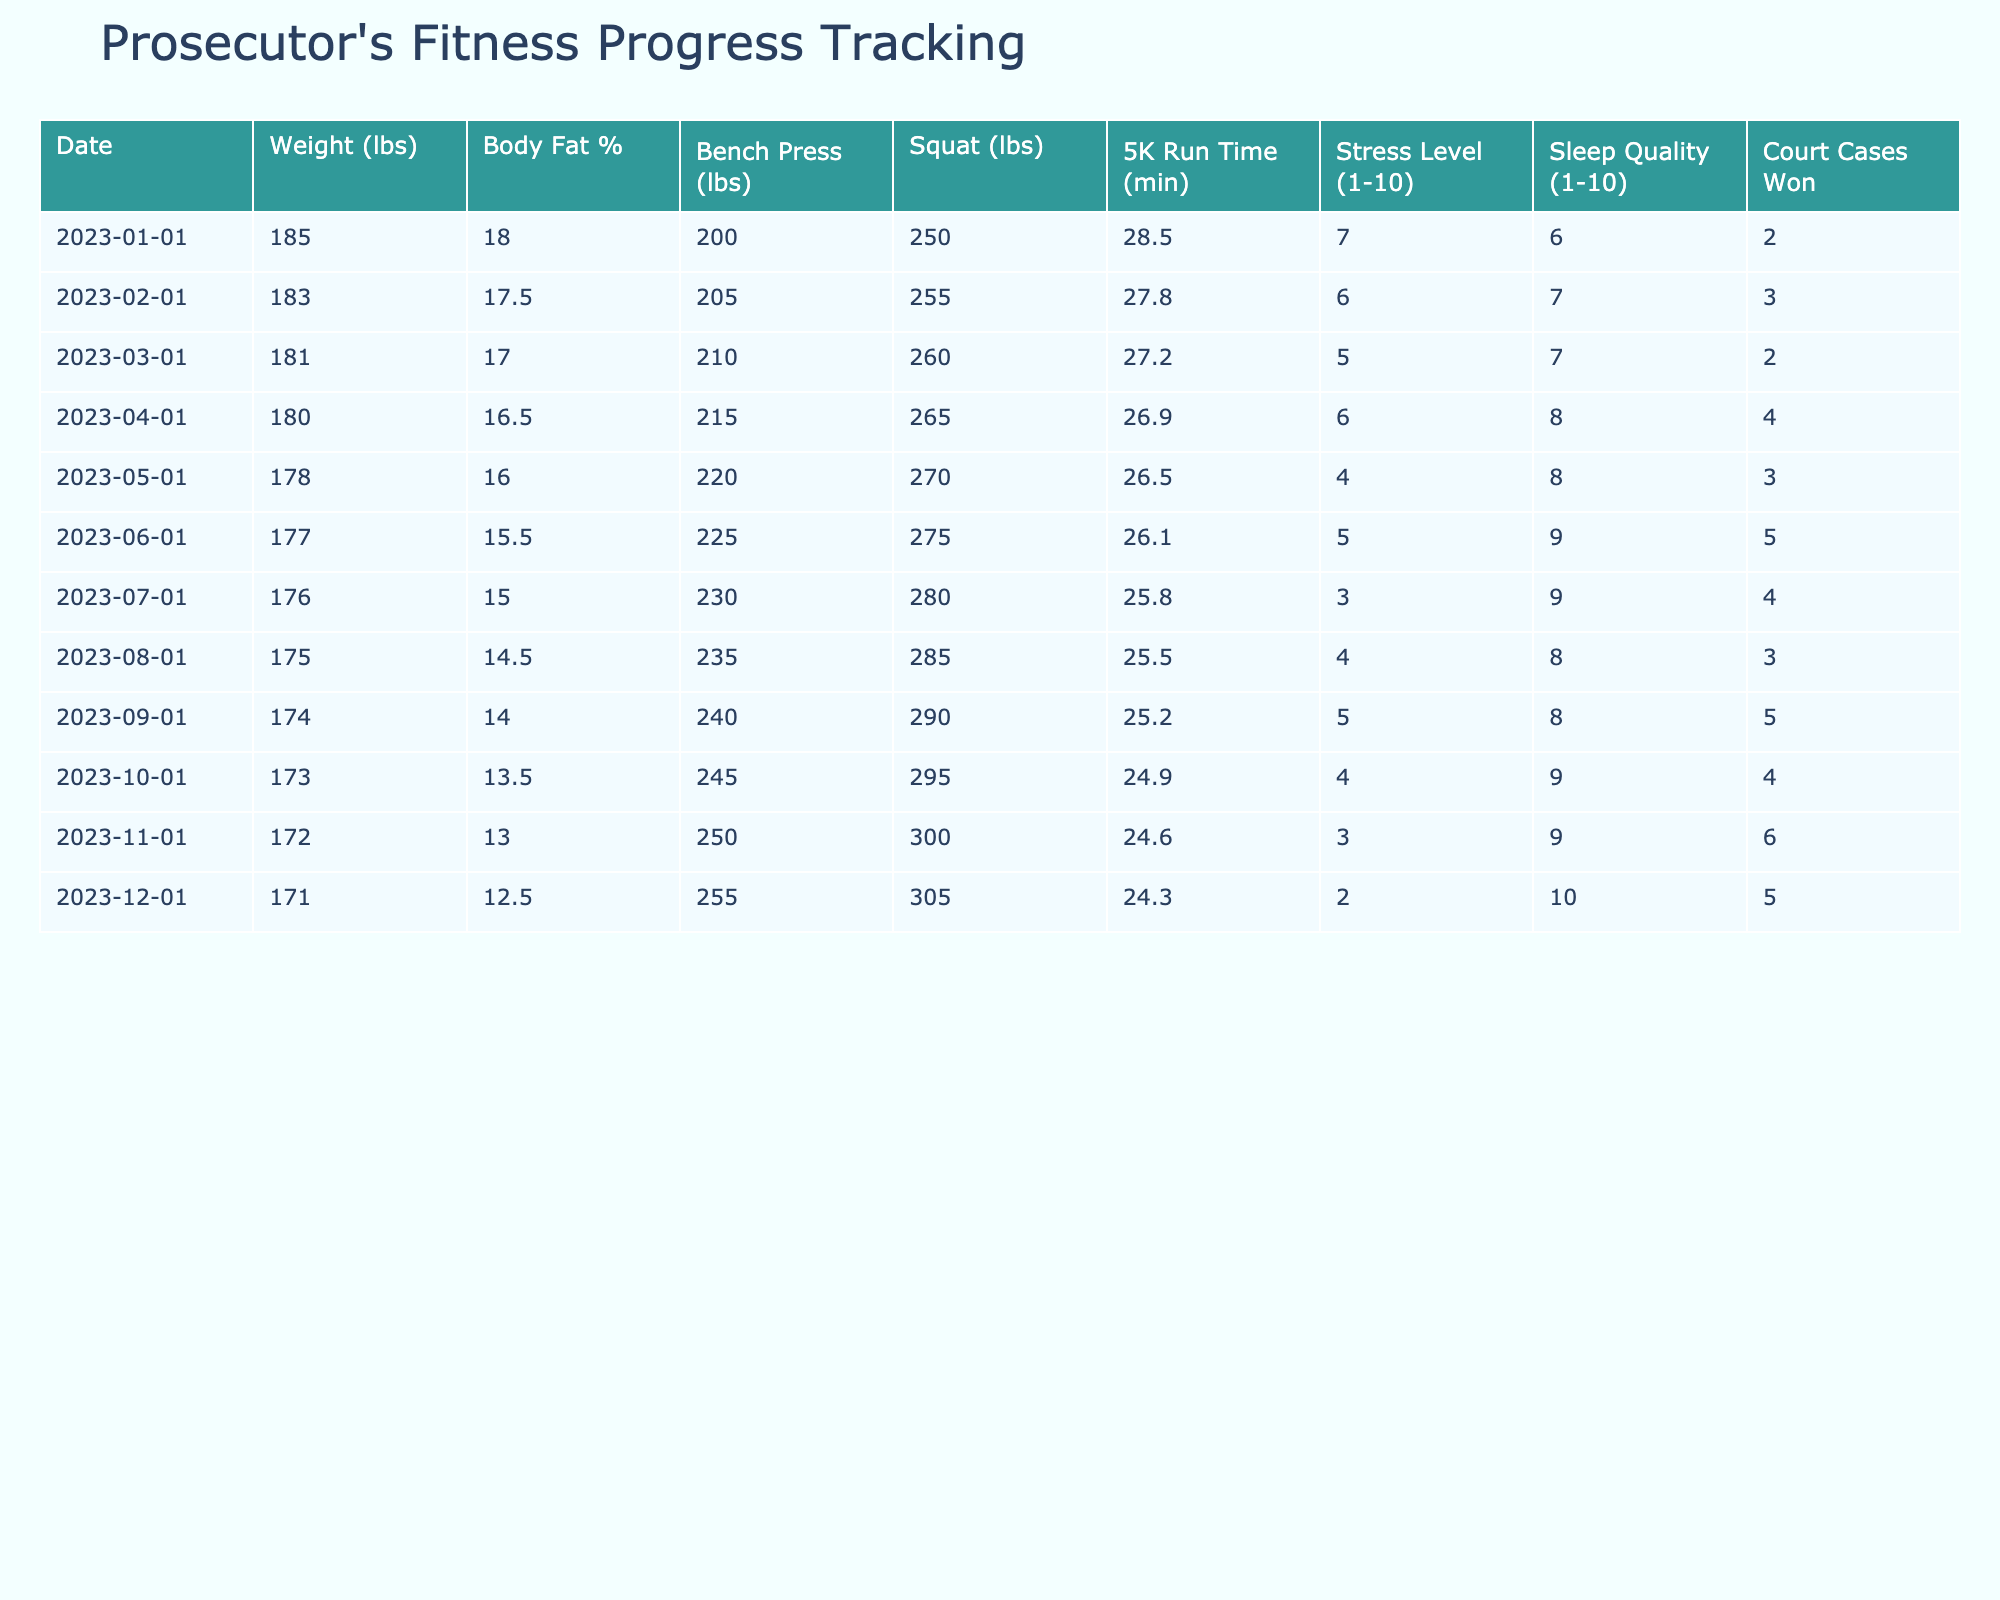What was the weight of the prosecutor on March 1, 2023? The table shows that on March 1, 2023, the weight recorded was 181 lbs.
Answer: 181 lbs What is the stress level on the date with the highest number of court cases won? The highest number of court cases won is 6, which occurred on November 1, 2023. The stress level on that date was 3.
Answer: 3 What is the average bench press weight from January to March 2023? The bench press weights from January to March are 200, 205, and 210 lbs. Adding these gives 200 + 205 + 210 = 615 lbs, and dividing by 3 gives an average of 615 / 3 = 205 lbs.
Answer: 205 lbs Did the prosecutor's body fat percentage decrease consistently every month? The body fat percentages show a decrease from 18% in January to 12.5% in December, indicating a consistent decrease each month.
Answer: Yes What was the change in the 5K run time from July to December 2023? The 5K run time on July 1, 2023, was 25.8 minutes, and on December 1, 2023, it was 24.3 minutes. The change is 25.8 - 24.3 = 1.5 minutes faster.
Answer: 1.5 minutes faster Which month had the lowest sleep quality rating and what was it? The table shows that the lowest sleep quality rating was 6, recorded in January 2023.
Answer: 6 What was the percentage drop in body fat from January to December 2023? The body fat percentage dropped from 18% in January to 12.5% in December. This is a decrease of 18 - 12.5 = 5.5%. To find the percentage drop: (5.5 / 18) * 100 ≈ 30.56%.
Answer: Approximately 30.56% In which month was the bench press weight the highest, and what was that weight? The highest bench press weight recorded was 255 lbs, which occurred in December 2023.
Answer: 255 lbs Compare the average stress level during the months with fewer than four court cases won to those with four or more. What is the difference? The months with fewer than four court cases are January (7), March (5), May (4), July (3), and August (4), giving an average of (7 + 5 + 4 + 3 + 4) / 5 = 4.6. The months with four or more cases are February (6), April (6), June (5), September (5), November (3), and December (2) for an average of (6 + 6 + 5 + 5 + 3 + 2) / 6 = 4.5. The difference is 4.6 - 4.5 = 0.1.
Answer: 0.1 What trend do you observe in court cases won over the year? The number of court cases won increased over the year from 2 in January to a peak of 6 in November before decreasing to 5 in December.
Answer: Increasing then peaks followed by a slight decrease 